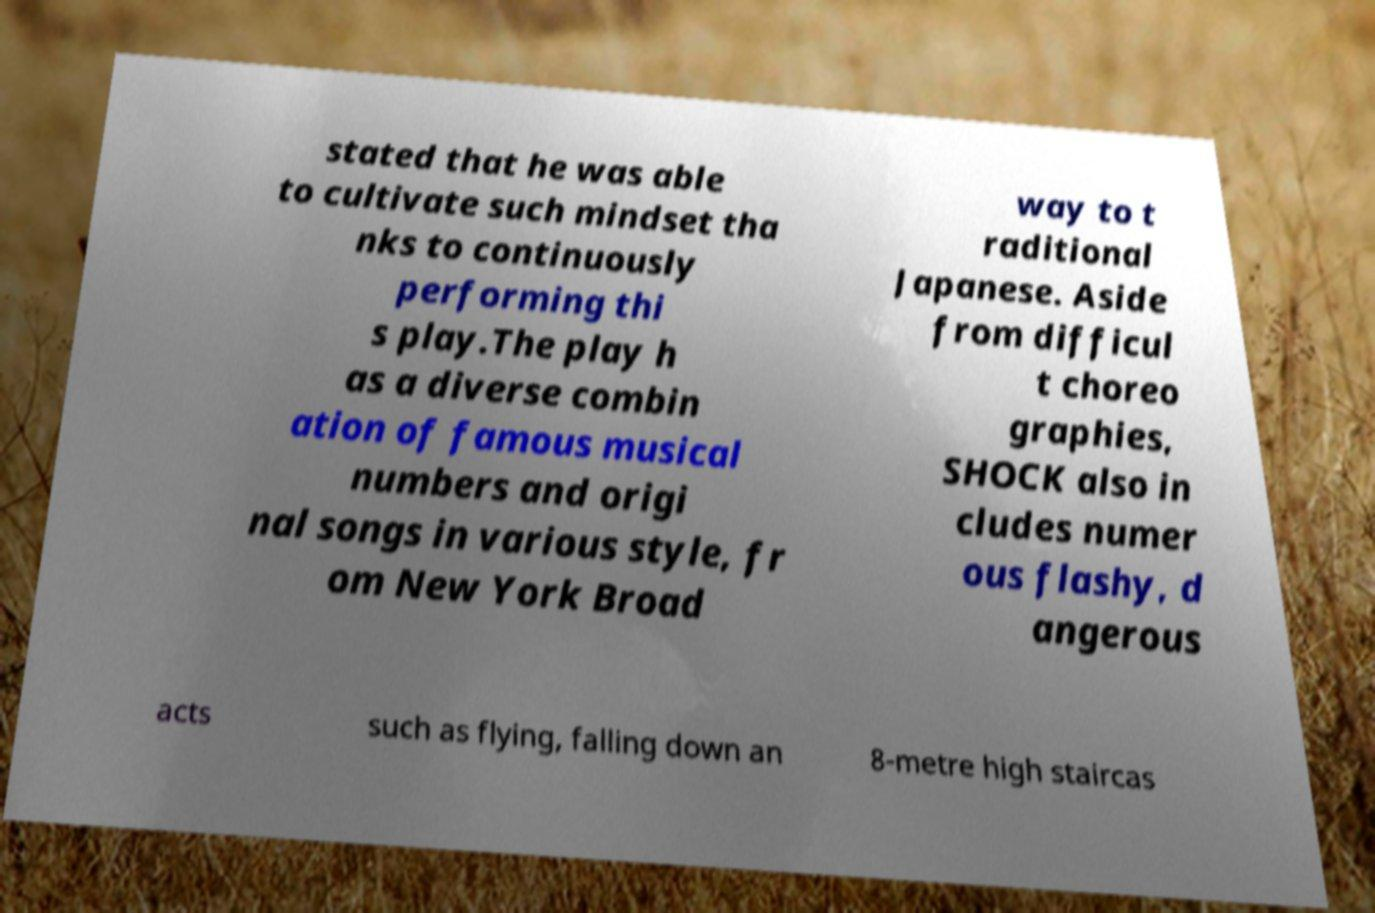Could you extract and type out the text from this image? stated that he was able to cultivate such mindset tha nks to continuously performing thi s play.The play h as a diverse combin ation of famous musical numbers and origi nal songs in various style, fr om New York Broad way to t raditional Japanese. Aside from difficul t choreo graphies, SHOCK also in cludes numer ous flashy, d angerous acts such as flying, falling down an 8-metre high staircas 